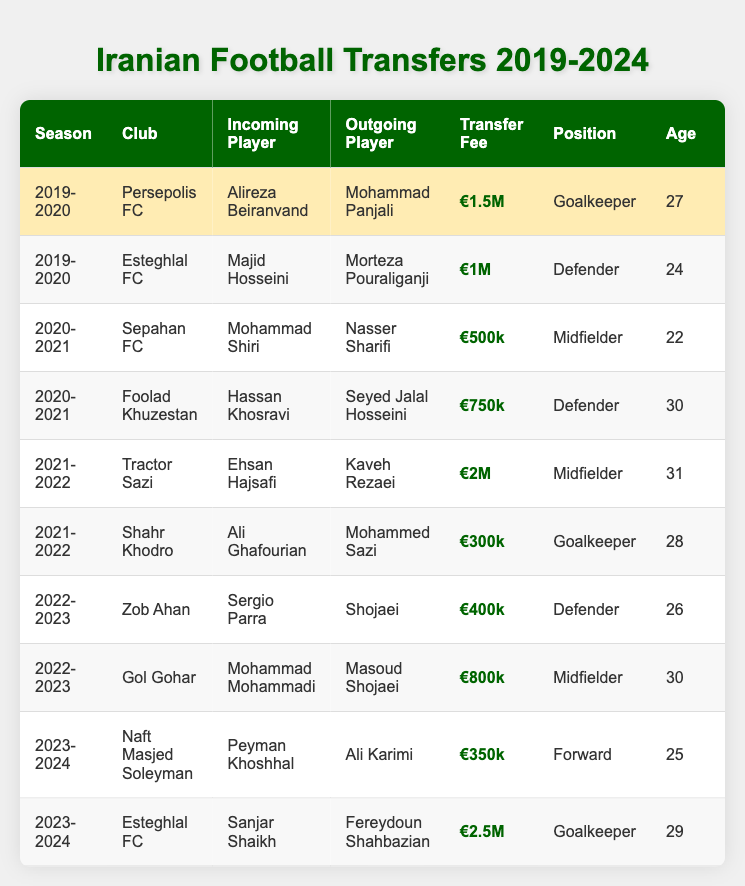What club did Alireza Beiranvand transfer to? The table shows that Alireza Beiranvand was transferred to Persepolis FC in the 2019-2020 season as an incoming player.
Answer: Persepolis FC What was the transfer fee for Sanjar Shaikh? The table indicates that the transfer fee for Sanjar Shaikh, who joined Esteghlal FC in the 2023-2024 season, was €2.5M.
Answer: €2.5M How many goalkeepers transferred in the 2021-2022 season? The table lists two goalkeepers who transferred in the 2021-2022 season: Alireza Beiranvand and Ali Ghafourian.
Answer: 2 Which player transferred out from Zob Ahan? According to the table, Shojaei was the outgoing player from Zob Ahan during the 2022-2023 season.
Answer: Shojaei What is the average age of the incoming players in the table? The ages of the incoming players are 27, 24, 22, 30, 31, 28, 26, 30, 25, and 29. Summing these ages gives 27 + 24 + 22 + 30 + 31 + 28 + 26 + 30 + 25 + 29 =  256. There are 10 players, so the average age is 256 / 10 = 25.6.
Answer: 25.6 Which incoming player had the highest transfer fee? The transfer fees listed are €1.5M, €1M, €500k, €750k, €2M, €300k, €400k, €800k, €350k, and €2.5M. The highest is €2.5M for Sanjar Shaikh.
Answer: €2.5M Did any player transfer to Foolad Khuzestan as an incoming player? The table shows that Hassan Khosravi transferred to Foolad Khuzestan during the 2020-2021 season, meaning the answer is yes.
Answer: Yes Which club had the most valuable outgoing transfer fee? By reviewing the fees, the highest outgoing fee listed is from Esteghlal FC with €2.5M, connected to the outgoing player Fereydoun Shahbazian in the 2023-2024 season.
Answer: Esteghlal FC What nationality is the incoming player for Gol Gohar? The table indicates that the incoming player for Gol Gohar, Mohammad Mohammadi, is Iranian.
Answer: Iran Were there any transfers involving players aged 30 or older? A review of the ages shows that Mohammad Shiri, Hassan Khosravi, Ehsan Hajsafi, and Ali Ghafourian were aged either 30 or older during their transfers. Thus, the answer is yes.
Answer: Yes 